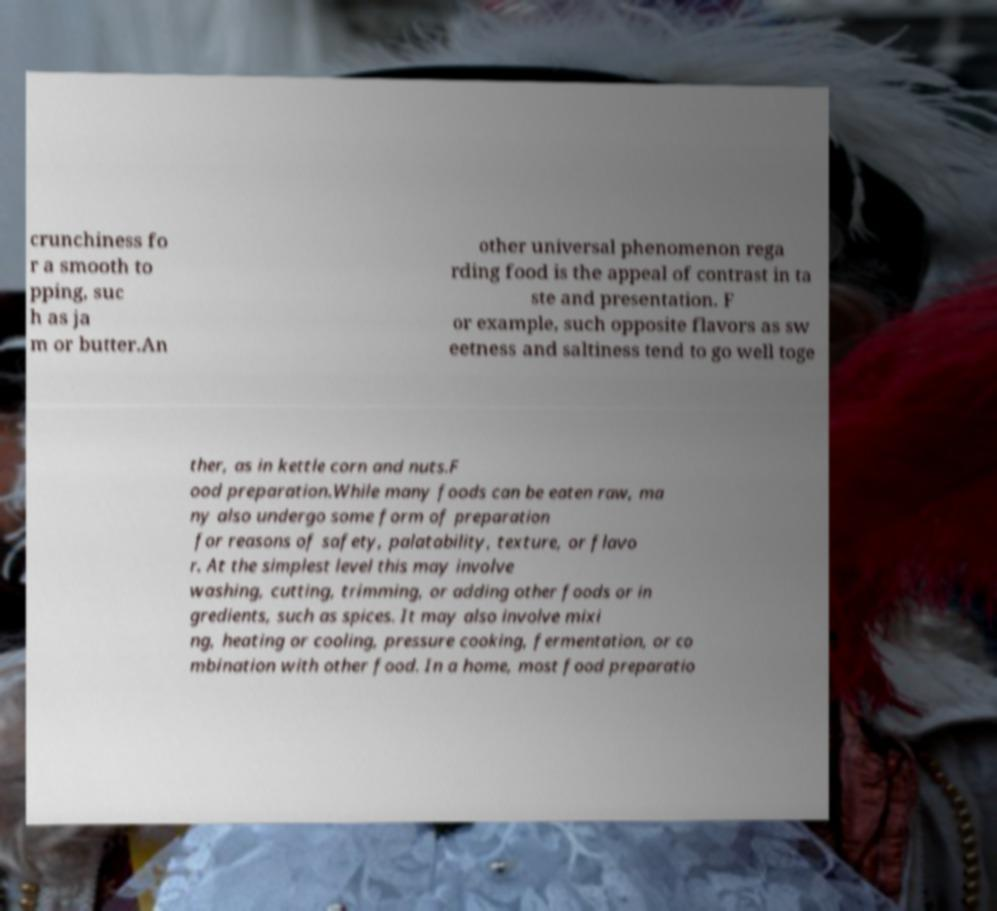I need the written content from this picture converted into text. Can you do that? crunchiness fo r a smooth to pping, suc h as ja m or butter.An other universal phenomenon rega rding food is the appeal of contrast in ta ste and presentation. F or example, such opposite flavors as sw eetness and saltiness tend to go well toge ther, as in kettle corn and nuts.F ood preparation.While many foods can be eaten raw, ma ny also undergo some form of preparation for reasons of safety, palatability, texture, or flavo r. At the simplest level this may involve washing, cutting, trimming, or adding other foods or in gredients, such as spices. It may also involve mixi ng, heating or cooling, pressure cooking, fermentation, or co mbination with other food. In a home, most food preparatio 